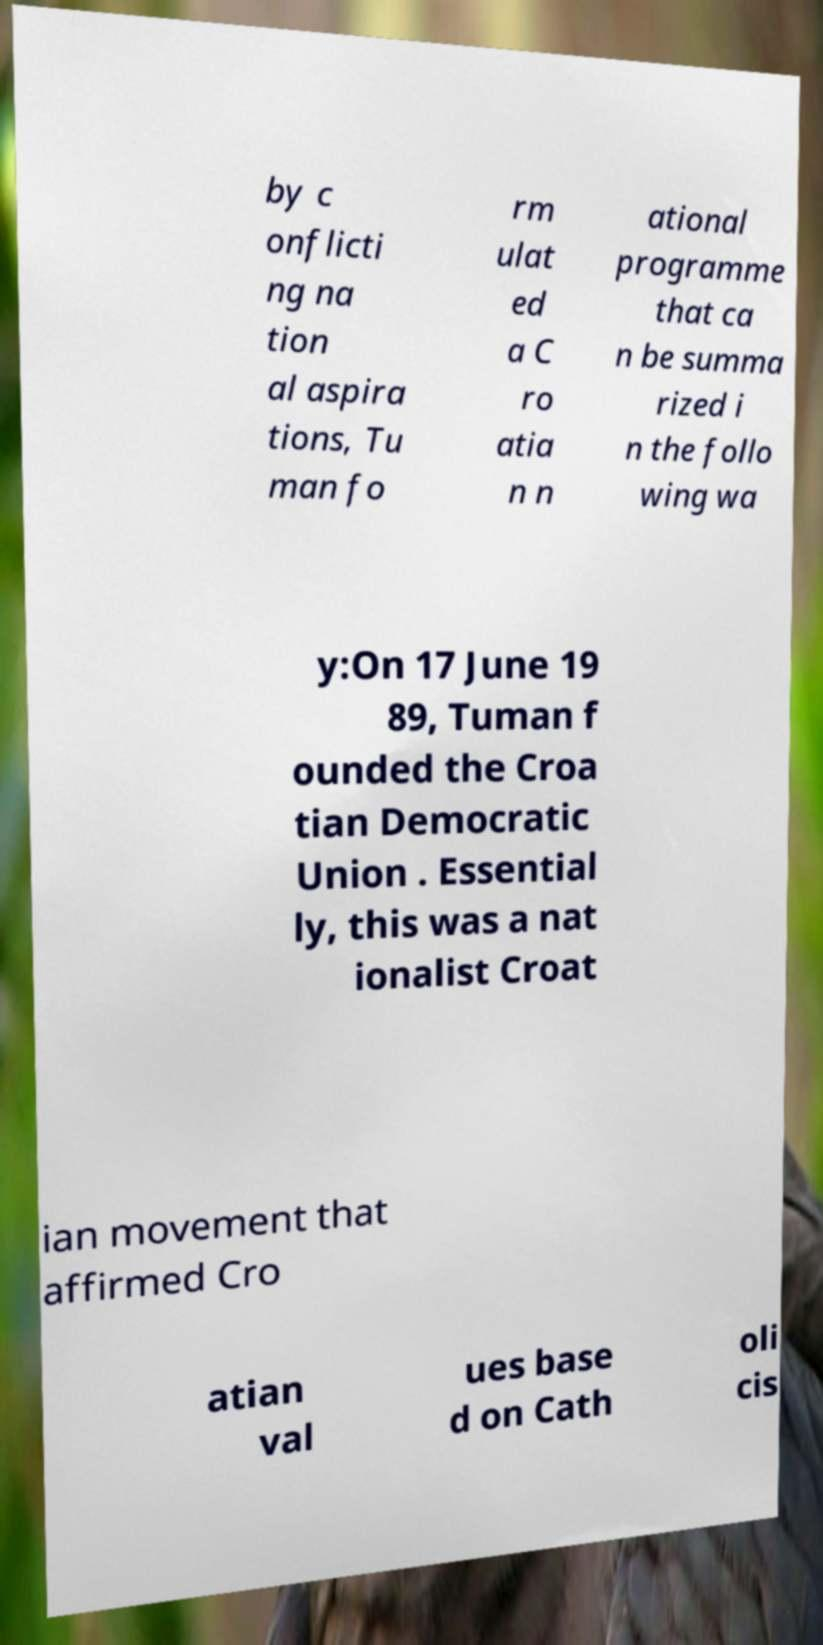Can you accurately transcribe the text from the provided image for me? by c onflicti ng na tion al aspira tions, Tu man fo rm ulat ed a C ro atia n n ational programme that ca n be summa rized i n the follo wing wa y:On 17 June 19 89, Tuman f ounded the Croa tian Democratic Union . Essential ly, this was a nat ionalist Croat ian movement that affirmed Cro atian val ues base d on Cath oli cis 